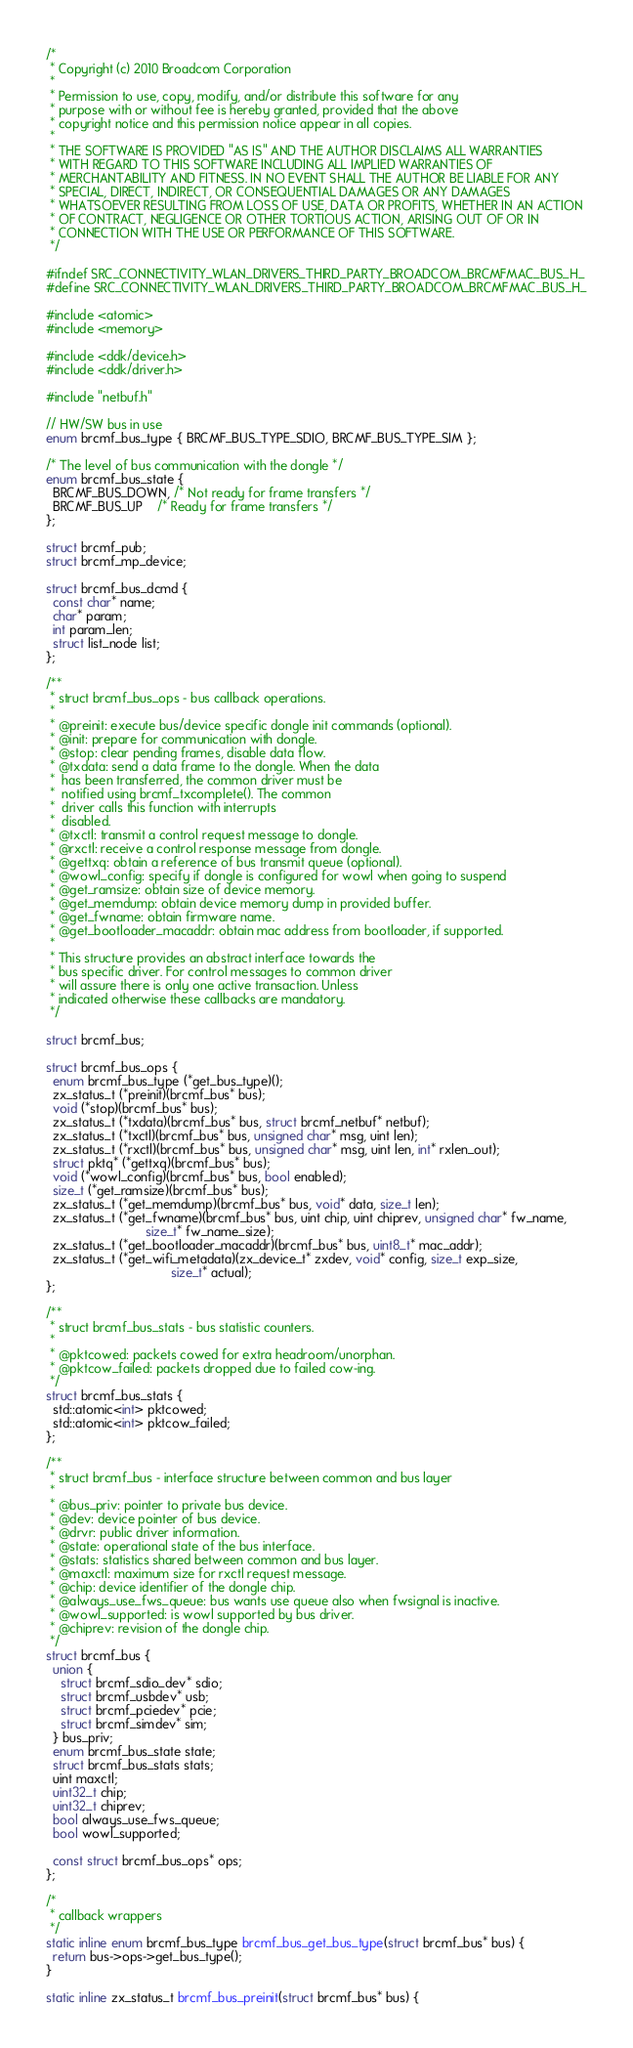Convert code to text. <code><loc_0><loc_0><loc_500><loc_500><_C_>/*
 * Copyright (c) 2010 Broadcom Corporation
 *
 * Permission to use, copy, modify, and/or distribute this software for any
 * purpose with or without fee is hereby granted, provided that the above
 * copyright notice and this permission notice appear in all copies.
 *
 * THE SOFTWARE IS PROVIDED "AS IS" AND THE AUTHOR DISCLAIMS ALL WARRANTIES
 * WITH REGARD TO THIS SOFTWARE INCLUDING ALL IMPLIED WARRANTIES OF
 * MERCHANTABILITY AND FITNESS. IN NO EVENT SHALL THE AUTHOR BE LIABLE FOR ANY
 * SPECIAL, DIRECT, INDIRECT, OR CONSEQUENTIAL DAMAGES OR ANY DAMAGES
 * WHATSOEVER RESULTING FROM LOSS OF USE, DATA OR PROFITS, WHETHER IN AN ACTION
 * OF CONTRACT, NEGLIGENCE OR OTHER TORTIOUS ACTION, ARISING OUT OF OR IN
 * CONNECTION WITH THE USE OR PERFORMANCE OF THIS SOFTWARE.
 */

#ifndef SRC_CONNECTIVITY_WLAN_DRIVERS_THIRD_PARTY_BROADCOM_BRCMFMAC_BUS_H_
#define SRC_CONNECTIVITY_WLAN_DRIVERS_THIRD_PARTY_BROADCOM_BRCMFMAC_BUS_H_

#include <atomic>
#include <memory>

#include <ddk/device.h>
#include <ddk/driver.h>

#include "netbuf.h"

// HW/SW bus in use
enum brcmf_bus_type { BRCMF_BUS_TYPE_SDIO, BRCMF_BUS_TYPE_SIM };

/* The level of bus communication with the dongle */
enum brcmf_bus_state {
  BRCMF_BUS_DOWN, /* Not ready for frame transfers */
  BRCMF_BUS_UP    /* Ready for frame transfers */
};

struct brcmf_pub;
struct brcmf_mp_device;

struct brcmf_bus_dcmd {
  const char* name;
  char* param;
  int param_len;
  struct list_node list;
};

/**
 * struct brcmf_bus_ops - bus callback operations.
 *
 * @preinit: execute bus/device specific dongle init commands (optional).
 * @init: prepare for communication with dongle.
 * @stop: clear pending frames, disable data flow.
 * @txdata: send a data frame to the dongle. When the data
 *  has been transferred, the common driver must be
 *  notified using brcmf_txcomplete(). The common
 *  driver calls this function with interrupts
 *  disabled.
 * @txctl: transmit a control request message to dongle.
 * @rxctl: receive a control response message from dongle.
 * @gettxq: obtain a reference of bus transmit queue (optional).
 * @wowl_config: specify if dongle is configured for wowl when going to suspend
 * @get_ramsize: obtain size of device memory.
 * @get_memdump: obtain device memory dump in provided buffer.
 * @get_fwname: obtain firmware name.
 * @get_bootloader_macaddr: obtain mac address from bootloader, if supported.
 *
 * This structure provides an abstract interface towards the
 * bus specific driver. For control messages to common driver
 * will assure there is only one active transaction. Unless
 * indicated otherwise these callbacks are mandatory.
 */

struct brcmf_bus;

struct brcmf_bus_ops {
  enum brcmf_bus_type (*get_bus_type)();
  zx_status_t (*preinit)(brcmf_bus* bus);
  void (*stop)(brcmf_bus* bus);
  zx_status_t (*txdata)(brcmf_bus* bus, struct brcmf_netbuf* netbuf);
  zx_status_t (*txctl)(brcmf_bus* bus, unsigned char* msg, uint len);
  zx_status_t (*rxctl)(brcmf_bus* bus, unsigned char* msg, uint len, int* rxlen_out);
  struct pktq* (*gettxq)(brcmf_bus* bus);
  void (*wowl_config)(brcmf_bus* bus, bool enabled);
  size_t (*get_ramsize)(brcmf_bus* bus);
  zx_status_t (*get_memdump)(brcmf_bus* bus, void* data, size_t len);
  zx_status_t (*get_fwname)(brcmf_bus* bus, uint chip, uint chiprev, unsigned char* fw_name,
                            size_t* fw_name_size);
  zx_status_t (*get_bootloader_macaddr)(brcmf_bus* bus, uint8_t* mac_addr);
  zx_status_t (*get_wifi_metadata)(zx_device_t* zxdev, void* config, size_t exp_size,
                                   size_t* actual);
};

/**
 * struct brcmf_bus_stats - bus statistic counters.
 *
 * @pktcowed: packets cowed for extra headroom/unorphan.
 * @pktcow_failed: packets dropped due to failed cow-ing.
 */
struct brcmf_bus_stats {
  std::atomic<int> pktcowed;
  std::atomic<int> pktcow_failed;
};

/**
 * struct brcmf_bus - interface structure between common and bus layer
 *
 * @bus_priv: pointer to private bus device.
 * @dev: device pointer of bus device.
 * @drvr: public driver information.
 * @state: operational state of the bus interface.
 * @stats: statistics shared between common and bus layer.
 * @maxctl: maximum size for rxctl request message.
 * @chip: device identifier of the dongle chip.
 * @always_use_fws_queue: bus wants use queue also when fwsignal is inactive.
 * @wowl_supported: is wowl supported by bus driver.
 * @chiprev: revision of the dongle chip.
 */
struct brcmf_bus {
  union {
    struct brcmf_sdio_dev* sdio;
    struct brcmf_usbdev* usb;
    struct brcmf_pciedev* pcie;
    struct brcmf_simdev* sim;
  } bus_priv;
  enum brcmf_bus_state state;
  struct brcmf_bus_stats stats;
  uint maxctl;
  uint32_t chip;
  uint32_t chiprev;
  bool always_use_fws_queue;
  bool wowl_supported;

  const struct brcmf_bus_ops* ops;
};

/*
 * callback wrappers
 */
static inline enum brcmf_bus_type brcmf_bus_get_bus_type(struct brcmf_bus* bus) {
  return bus->ops->get_bus_type();
}

static inline zx_status_t brcmf_bus_preinit(struct brcmf_bus* bus) {</code> 